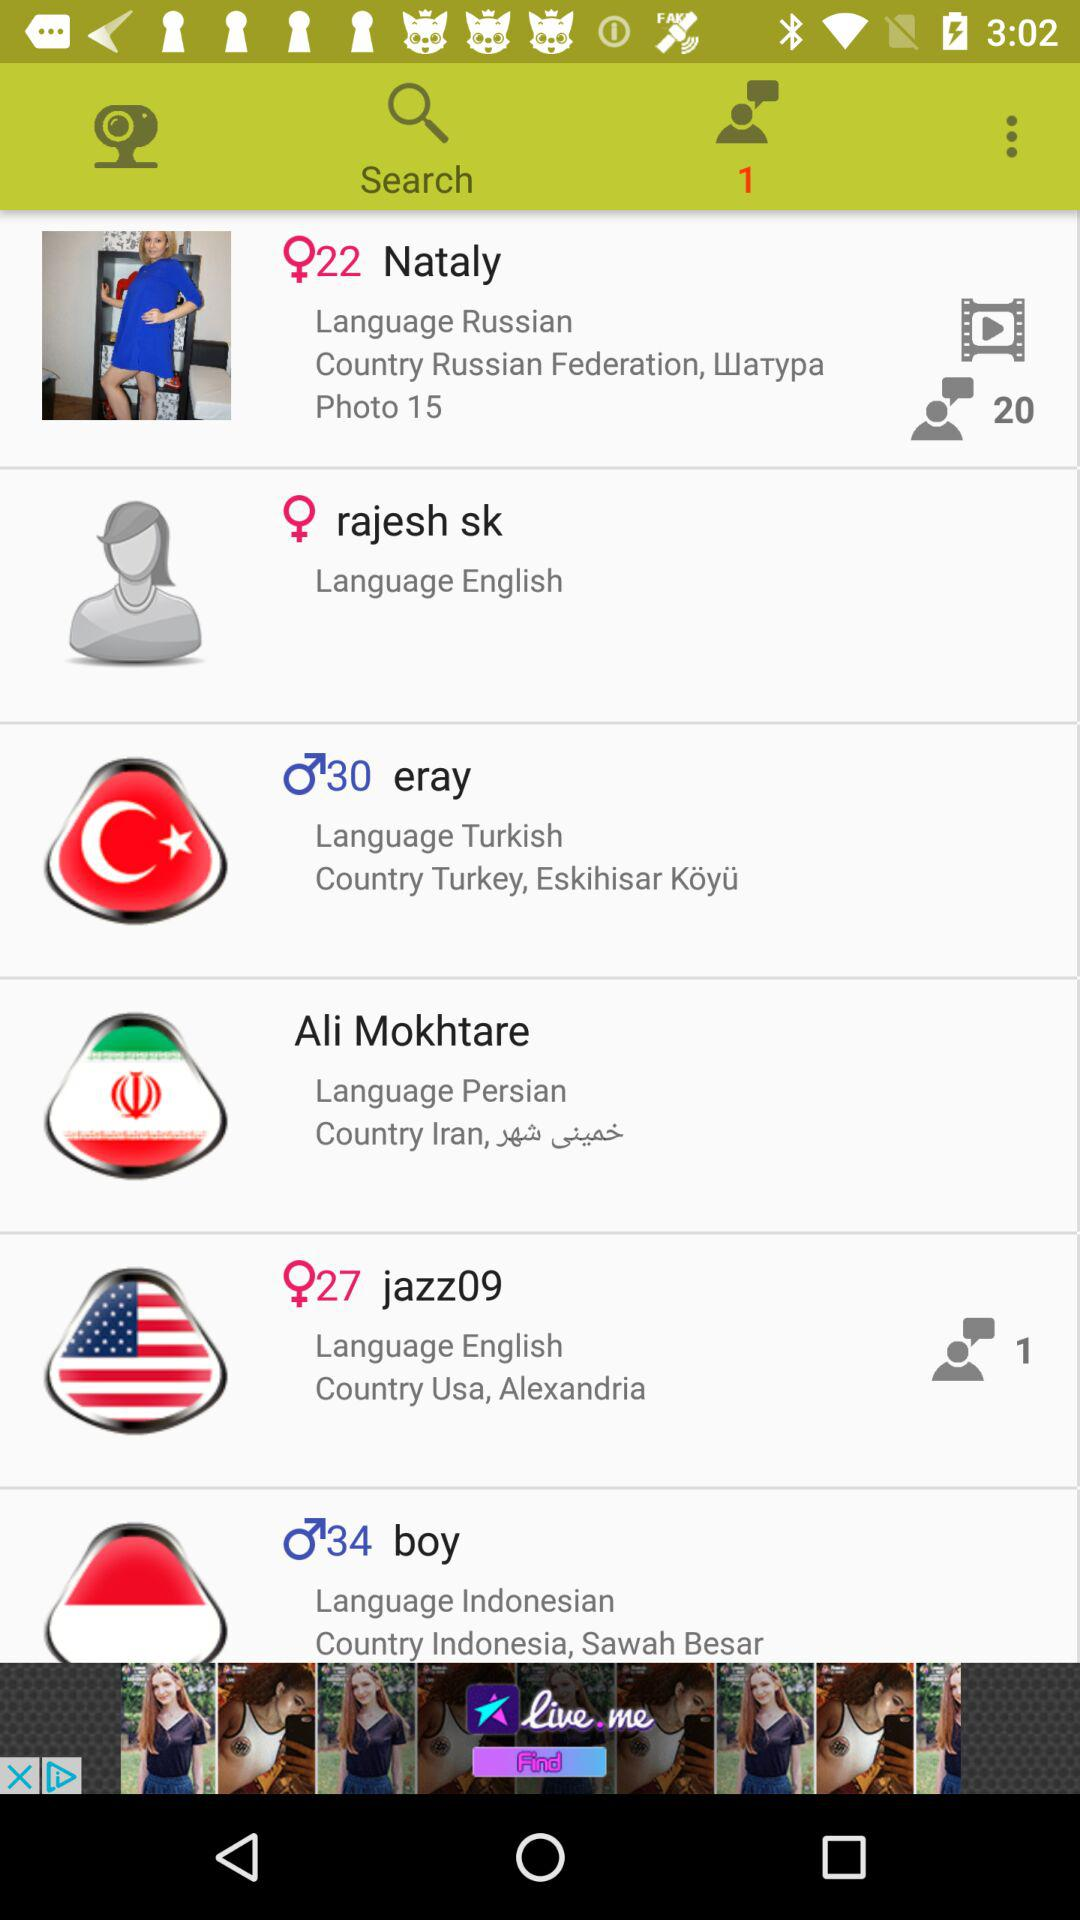Which user is from the United States? The one who is from the United States is the user "jazz09". 